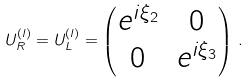Convert formula to latex. <formula><loc_0><loc_0><loc_500><loc_500>U _ { R } ^ { ( l ) } = U _ { L } ^ { ( l ) } = \begin{pmatrix} e ^ { i \xi _ { 2 } } & 0 \\ 0 & e ^ { i \xi _ { 3 } } \end{pmatrix} \, .</formula> 